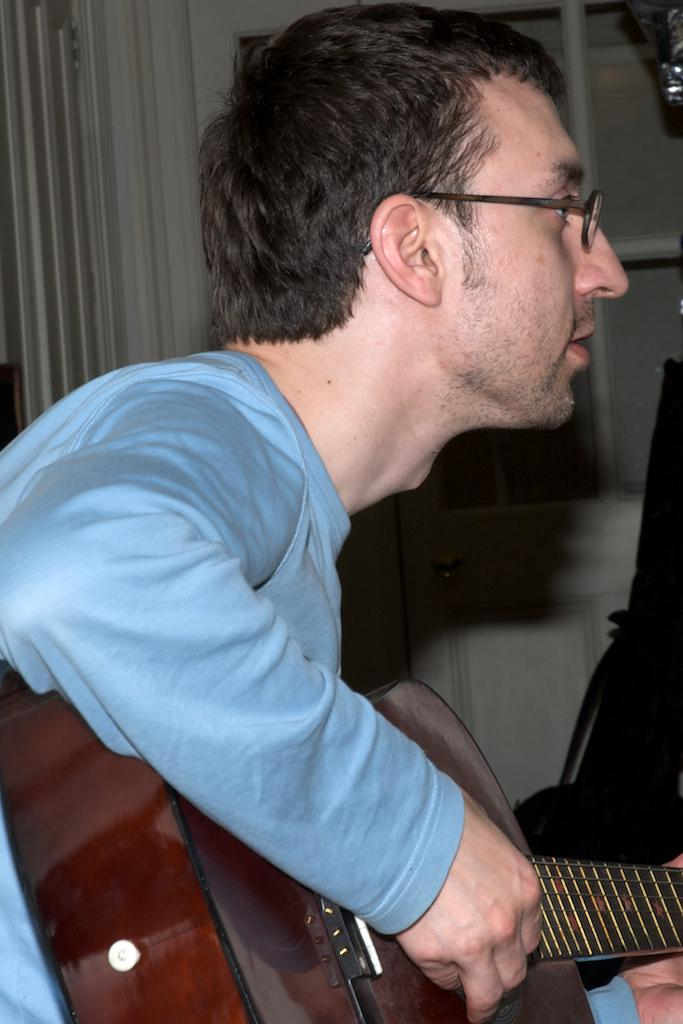What is the main subject of the image? There is a person in the image. What is the person holding in his hand? The person is holding a guitar in his hand. Where is the person's mom standing in the image? There is no mention of a mom or anyone else standing in the image, so we cannot answer this question. 